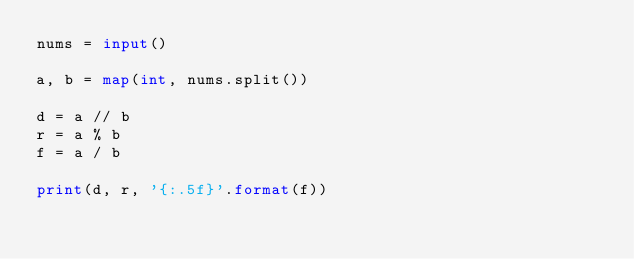Convert code to text. <code><loc_0><loc_0><loc_500><loc_500><_Python_>nums = input()

a, b = map(int, nums.split())

d = a // b
r = a % b
f = a / b

print(d, r, '{:.5f}'.format(f))
</code> 